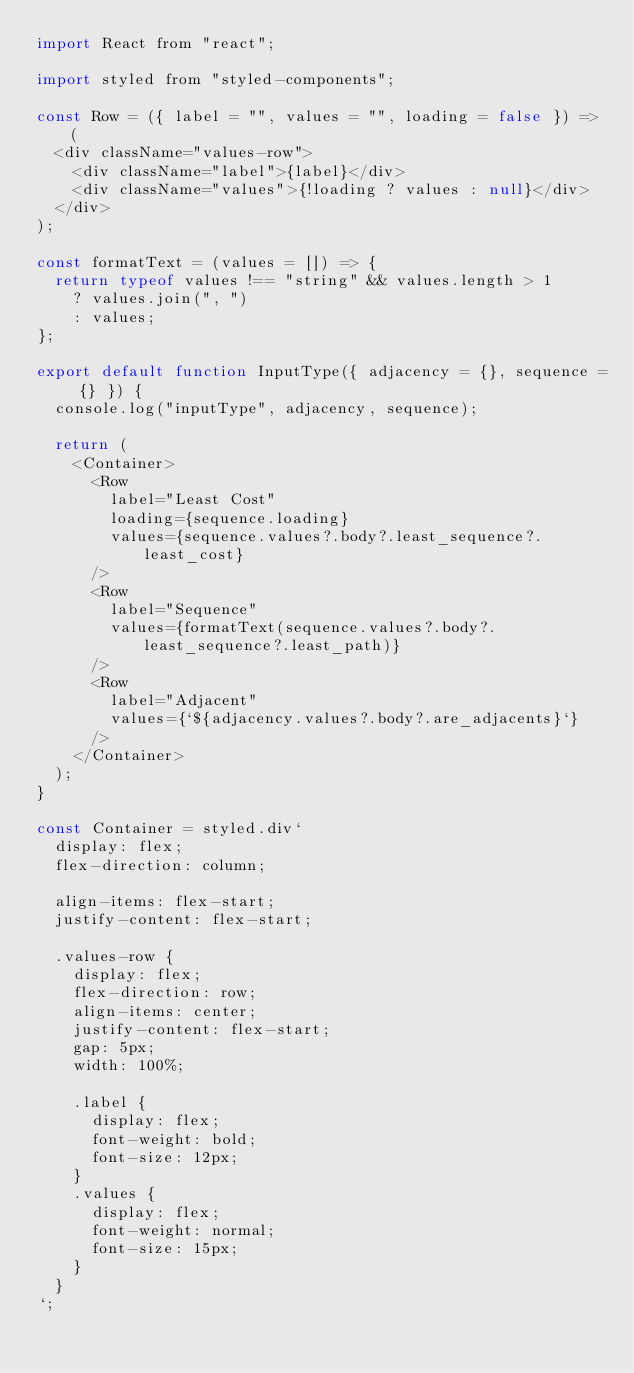<code> <loc_0><loc_0><loc_500><loc_500><_JavaScript_>import React from "react";

import styled from "styled-components";

const Row = ({ label = "", values = "", loading = false }) => (
  <div className="values-row">
    <div className="label">{label}</div>
    <div className="values">{!loading ? values : null}</div>
  </div>
);

const formatText = (values = []) => {
  return typeof values !== "string" && values.length > 1
    ? values.join(", ")
    : values;
};

export default function InputType({ adjacency = {}, sequence = {} }) {
  console.log("inputType", adjacency, sequence);

  return (
    <Container>
      <Row
        label="Least Cost"
        loading={sequence.loading}
        values={sequence.values?.body?.least_sequence?.least_cost}
      />
      <Row
        label="Sequence"
        values={formatText(sequence.values?.body?.least_sequence?.least_path)}
      />
      <Row
        label="Adjacent"
        values={`${adjacency.values?.body?.are_adjacents}`}
      />
    </Container>
  );
}

const Container = styled.div`
  display: flex;
  flex-direction: column;

  align-items: flex-start;
  justify-content: flex-start;

  .values-row {
    display: flex;
    flex-direction: row;
    align-items: center;
    justify-content: flex-start;
    gap: 5px;
    width: 100%;

    .label {
      display: flex;
      font-weight: bold;
      font-size: 12px;
    }
    .values {
      display: flex;
      font-weight: normal;
      font-size: 15px;
    }
  }
`;
</code> 